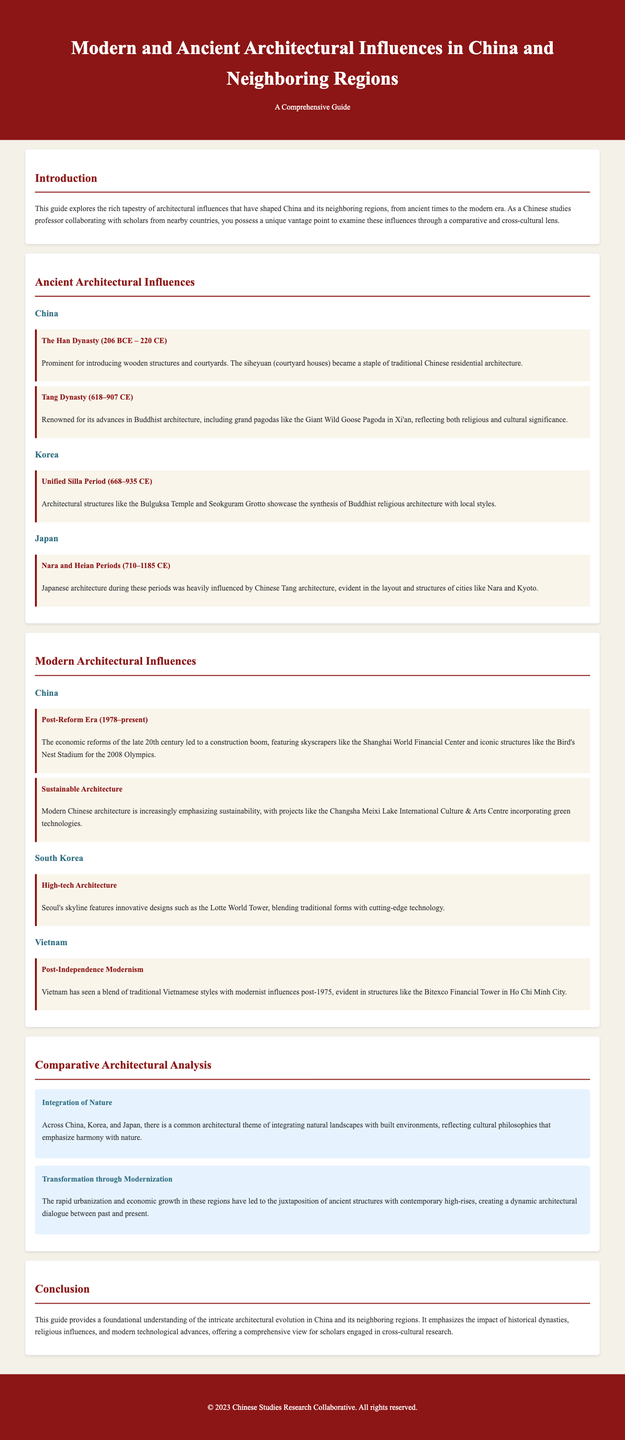What architectural style became a staple in traditional Chinese residential architecture? The document mentions that siheyuan (courtyard houses) became a staple of traditional Chinese residential architecture introduced during the Han Dynasty.
Answer: siheyuan Which dynasty is known for advances in Buddhist architecture? According to the document, the Tang Dynasty is renowned for its advances in Buddhist architecture, including grand pagodas.
Answer: Tang Dynasty What period does the document mention as the Post-Reform Era in China? The document states that the Post-Reform Era refers to the period from 1978 to the present.
Answer: 1978–present What theme reflects the integration of natural landscapes with built environments? The document describes the theme of "Integration of Nature" as a common architectural theme across China, Korea, and Japan.
Answer: Integration of Nature Which structure from Vietnam exemplifies Post-Independence Modernism? The document lists the Bitexco Financial Tower in Ho Chi Minh City as a structure that exhibits Post-Independence Modernism in Vietnam.
Answer: Bitexco Financial Tower What architectural feature is prominent in structures from the Unified Silla Period? The document indicates that the architectural structures from the Unified Silla Period include the Bulguksa Temple and Seokguram Grotto.
Answer: Bulguksa Temple How does the document describe modern Chinese architecture's emphasis on sustainability? The document mentions that modern Chinese architecture is increasingly emphasizing sustainability, with examples like the Changsha Meixi Lake International Culture & Arts Centre.
Answer: sustainability What common development does the document mention regarding urbanization in these regions? The document highlights the "Transformation through Modernization" theme, emphasizing the juxtaposition of ancient structures with contemporary high-rises.
Answer: Transformation through Modernization Which period does Japanese architecture heavily draw influences from Chinese architecture? The document states that Japanese architecture during the Nara and Heian Periods was heavily influenced by Chinese Tang architecture.
Answer: Nara and Heian Periods 